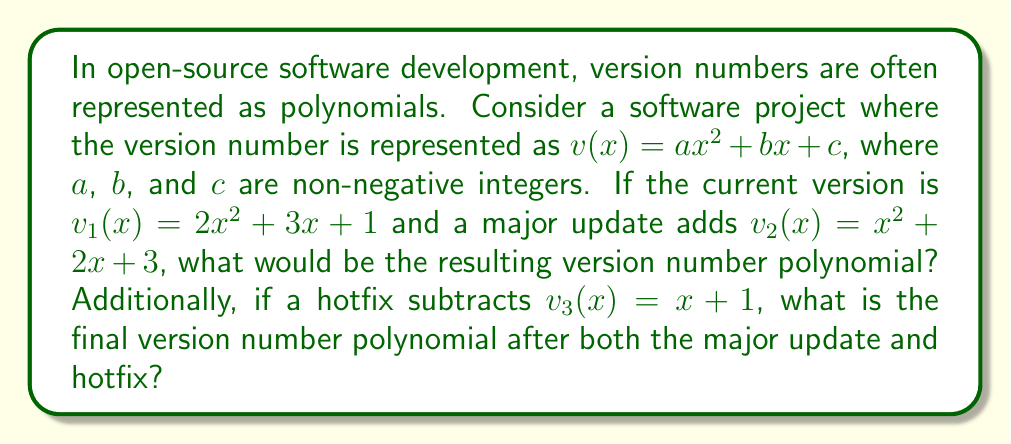Could you help me with this problem? Let's approach this step-by-step:

1) First, we need to add the current version $v_1(x)$ and the major update $v_2(x)$:

   $v_1(x) + v_2(x) = (2x^2 + 3x + 1) + (x^2 + 2x + 3)$

2) To add these polynomials, we combine like terms:

   $(2x^2 + x^2) + (3x + 2x) + (1 + 3)$
   $= 3x^2 + 5x + 4$

3) This gives us the intermediate version after the major update. Let's call this $v_i(x)$:

   $v_i(x) = 3x^2 + 5x + 4$

4) Now, we need to subtract the hotfix $v_3(x)$ from this intermediate version:

   $v_i(x) - v_3(x) = (3x^2 + 5x + 4) - (x + 1)$

5) Subtracting polynomials means subtracting the coefficients of like terms:

   $3x^2 + (5x - x) + (4 - 1)$
   $= 3x^2 + 4x + 3$

6) This gives us our final version number polynomial after both the major update and hotfix.
Answer: $3x^2 + 4x + 3$ 